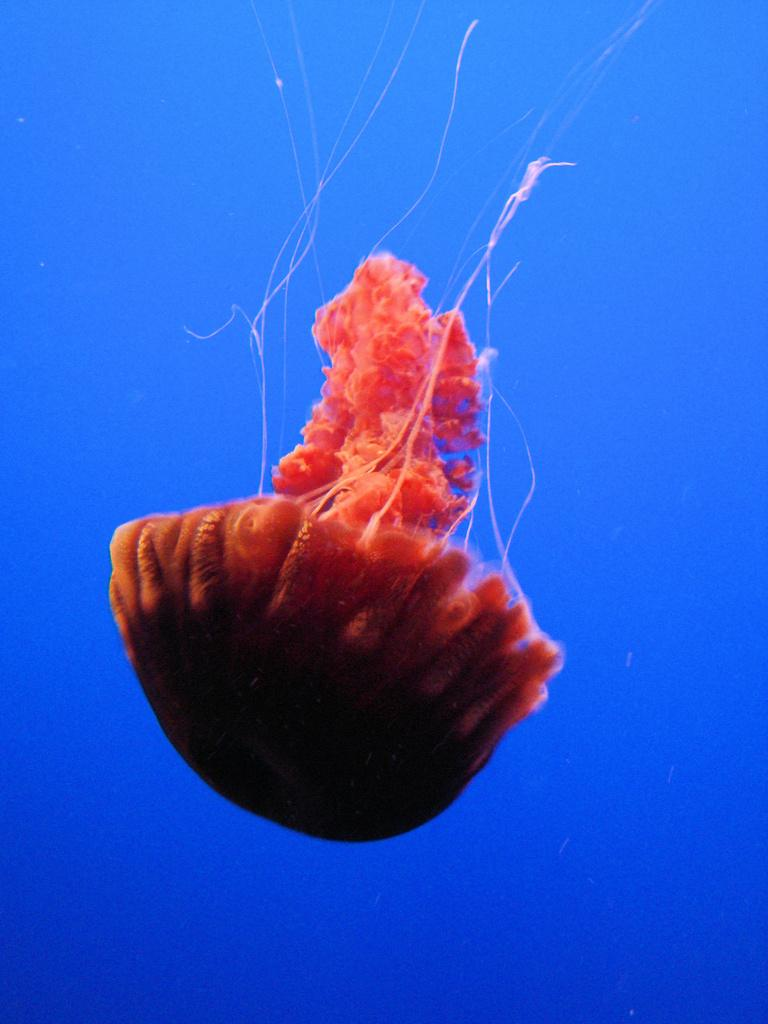What type of sea creature is in the image? There is a jellyfish in the image. What type of ship can be seen sailing in the image? There is no ship present in the image; it features a jellyfish. What type of laborer is working in the image? There is no laborer present in the image; it features a jellyfish. 